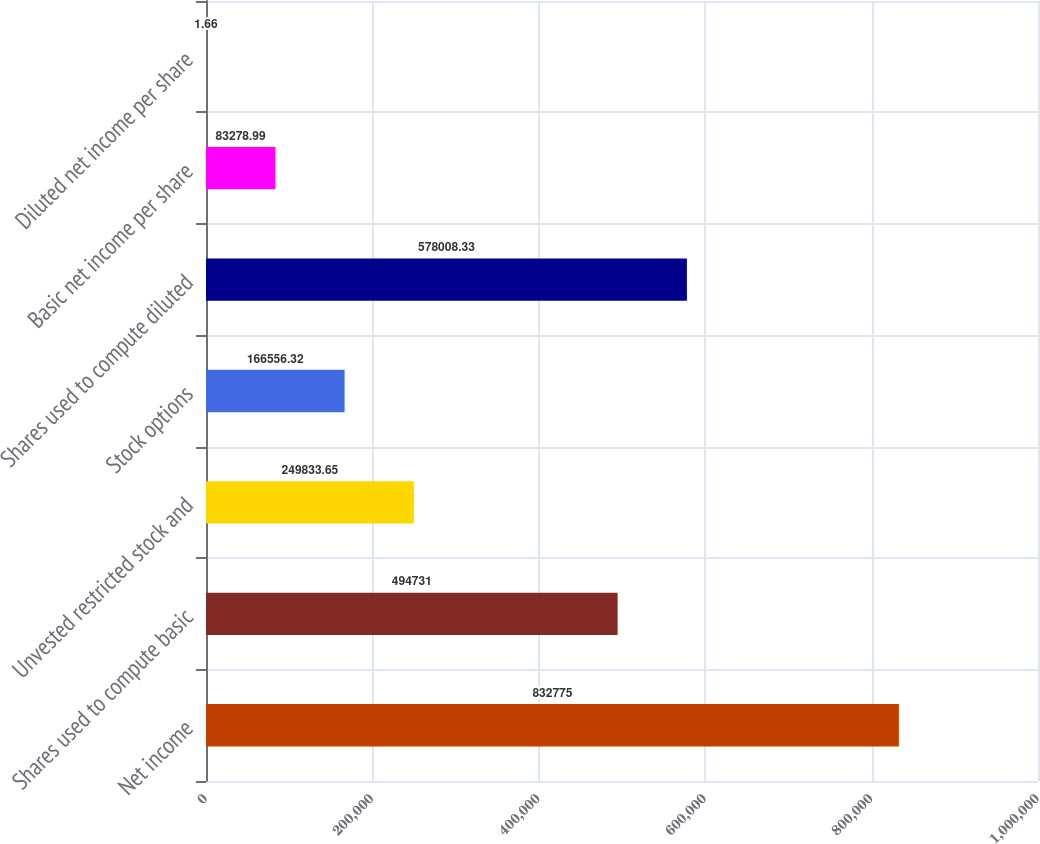Convert chart to OTSL. <chart><loc_0><loc_0><loc_500><loc_500><bar_chart><fcel>Net income<fcel>Shares used to compute basic<fcel>Unvested restricted stock and<fcel>Stock options<fcel>Shares used to compute diluted<fcel>Basic net income per share<fcel>Diluted net income per share<nl><fcel>832775<fcel>494731<fcel>249834<fcel>166556<fcel>578008<fcel>83279<fcel>1.66<nl></chart> 